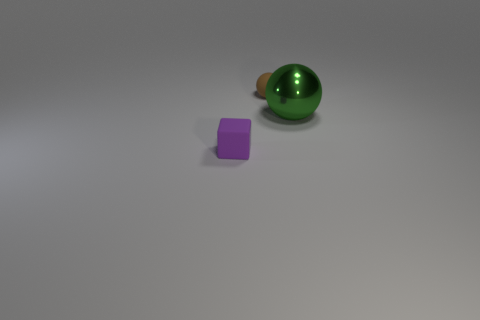Add 2 big yellow metallic balls. How many objects exist? 5 Subtract all brown balls. How many balls are left? 1 Subtract all spheres. How many objects are left? 1 Subtract all large green metallic things. Subtract all big green spheres. How many objects are left? 1 Add 1 large objects. How many large objects are left? 2 Add 2 large green shiny balls. How many large green shiny balls exist? 3 Subtract 0 red cylinders. How many objects are left? 3 Subtract 1 balls. How many balls are left? 1 Subtract all green cubes. Subtract all yellow balls. How many cubes are left? 1 Subtract all blue balls. How many cyan blocks are left? 0 